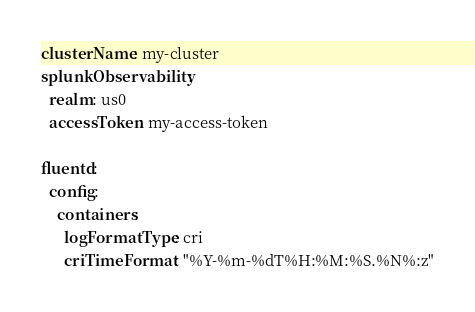Convert code to text. <code><loc_0><loc_0><loc_500><loc_500><_YAML_>clusterName: my-cluster
splunkObservability:
  realm: us0
  accessToken: my-access-token

fluentd:
  config:
    containers:
      logFormatType: cri
      criTimeFormat: "%Y-%m-%dT%H:%M:%S.%N%:z"
</code> 